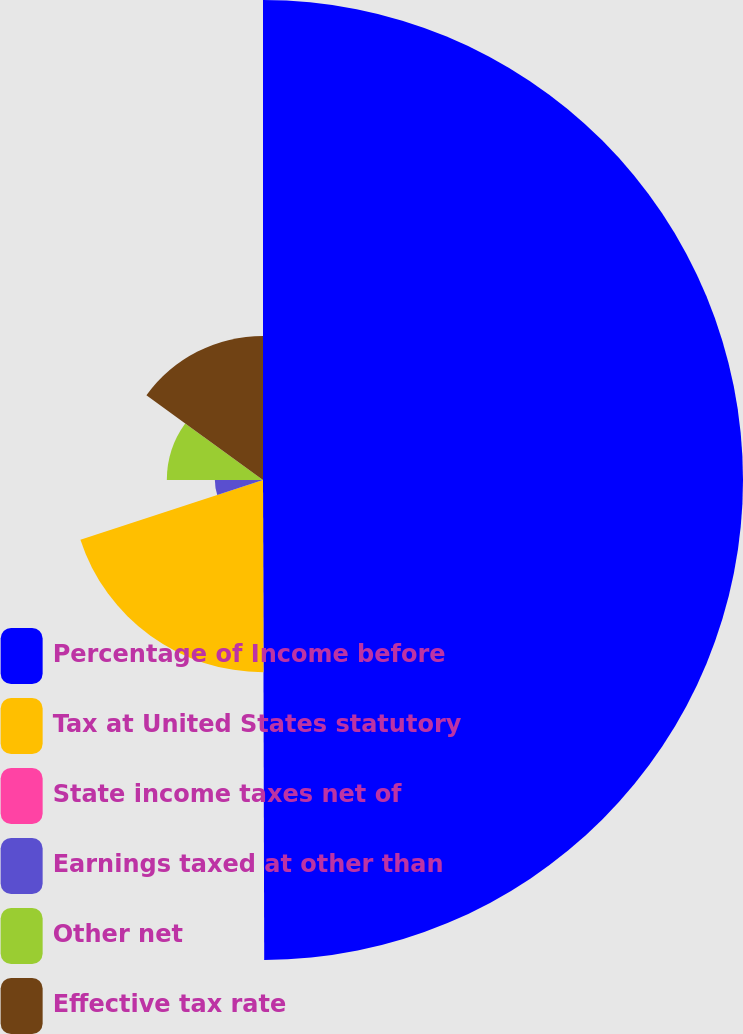Convert chart to OTSL. <chart><loc_0><loc_0><loc_500><loc_500><pie_chart><fcel>Percentage of Income before<fcel>Tax at United States statutory<fcel>State income taxes net of<fcel>Earnings taxed at other than<fcel>Other net<fcel>Effective tax rate<nl><fcel>49.96%<fcel>20.0%<fcel>0.02%<fcel>5.01%<fcel>10.01%<fcel>15.0%<nl></chart> 